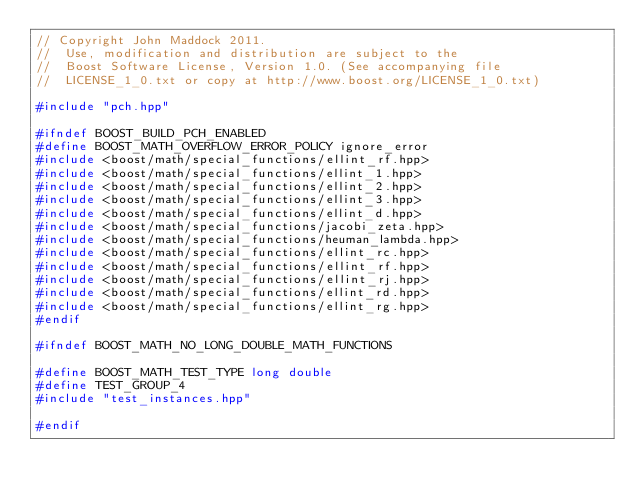Convert code to text. <code><loc_0><loc_0><loc_500><loc_500><_C++_>// Copyright John Maddock 2011.
//  Use, modification and distribution are subject to the
//  Boost Software License, Version 1.0. (See accompanying file
//  LICENSE_1_0.txt or copy at http://www.boost.org/LICENSE_1_0.txt)

#include "pch.hpp"

#ifndef BOOST_BUILD_PCH_ENABLED
#define BOOST_MATH_OVERFLOW_ERROR_POLICY ignore_error
#include <boost/math/special_functions/ellint_rf.hpp>
#include <boost/math/special_functions/ellint_1.hpp>
#include <boost/math/special_functions/ellint_2.hpp>
#include <boost/math/special_functions/ellint_3.hpp>
#include <boost/math/special_functions/ellint_d.hpp>
#include <boost/math/special_functions/jacobi_zeta.hpp>
#include <boost/math/special_functions/heuman_lambda.hpp>
#include <boost/math/special_functions/ellint_rc.hpp>
#include <boost/math/special_functions/ellint_rf.hpp>
#include <boost/math/special_functions/ellint_rj.hpp>
#include <boost/math/special_functions/ellint_rd.hpp>
#include <boost/math/special_functions/ellint_rg.hpp>
#endif

#ifndef BOOST_MATH_NO_LONG_DOUBLE_MATH_FUNCTIONS

#define BOOST_MATH_TEST_TYPE long double
#define TEST_GROUP_4
#include "test_instances.hpp"

#endif
</code> 